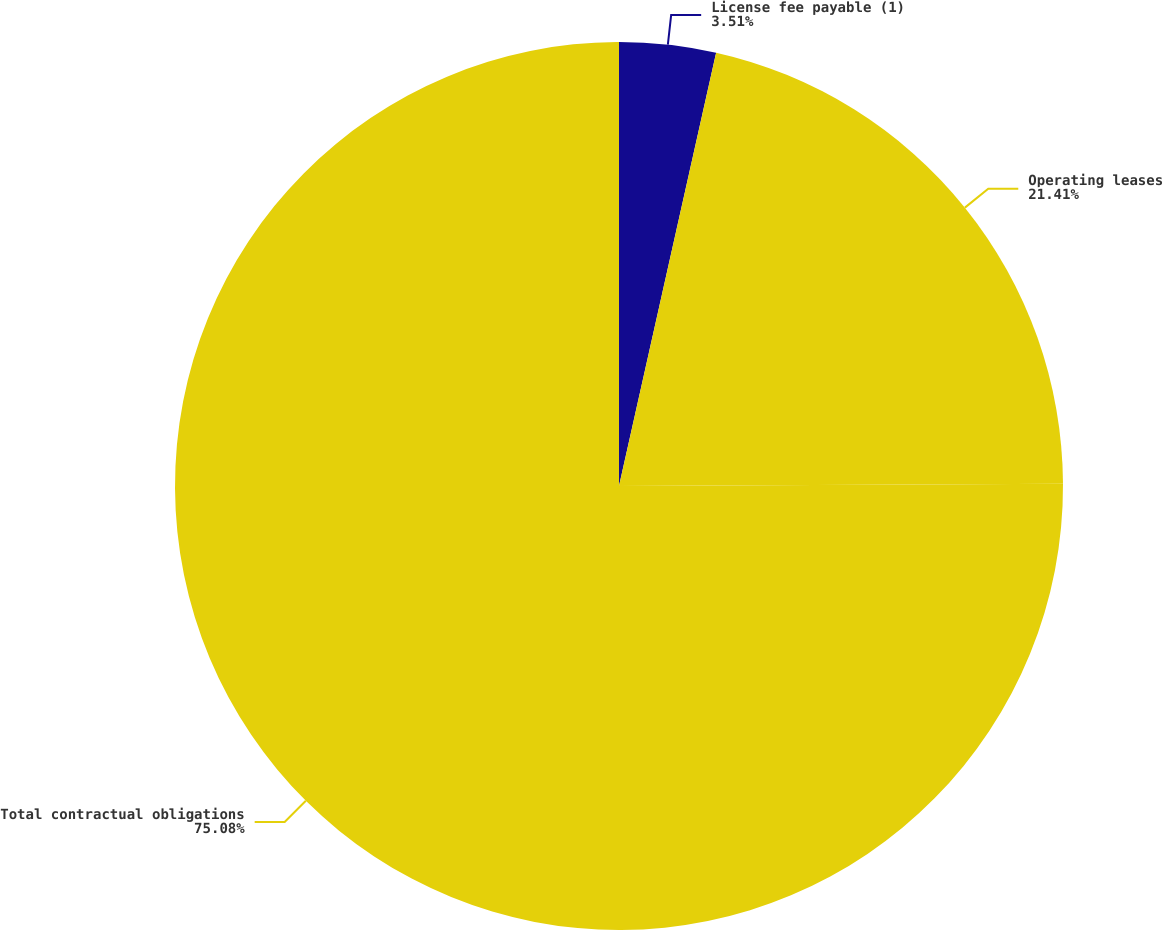Convert chart to OTSL. <chart><loc_0><loc_0><loc_500><loc_500><pie_chart><fcel>License fee payable (1)<fcel>Operating leases<fcel>Total contractual obligations<nl><fcel>3.51%<fcel>21.41%<fcel>75.08%<nl></chart> 